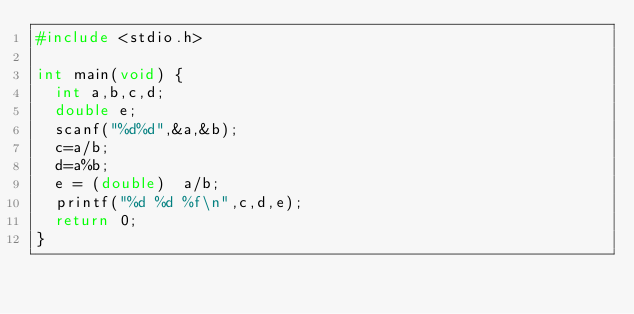Convert code to text. <code><loc_0><loc_0><loc_500><loc_500><_C_>#include <stdio.h>

int main(void) {
	int a,b,c,d;
	double e;
	scanf("%d%d",&a,&b);
	c=a/b;
	d=a%b;
	e = (double)  a/b;
	printf("%d %d %f\n",c,d,e);
	return 0;
}</code> 